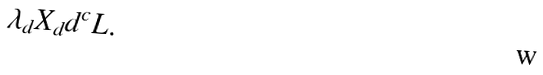Convert formula to latex. <formula><loc_0><loc_0><loc_500><loc_500>\lambda _ { d } X _ { d } d ^ { c } L .</formula> 